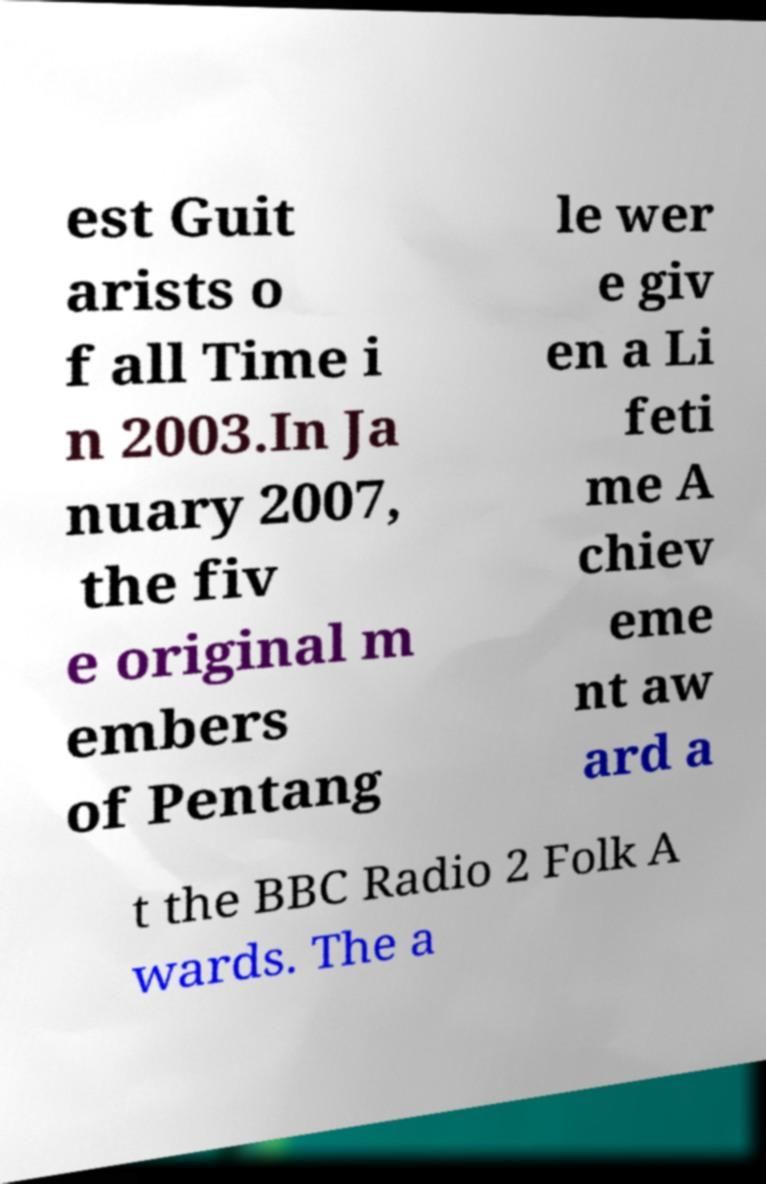Can you accurately transcribe the text from the provided image for me? est Guit arists o f all Time i n 2003.In Ja nuary 2007, the fiv e original m embers of Pentang le wer e giv en a Li feti me A chiev eme nt aw ard a t the BBC Radio 2 Folk A wards. The a 